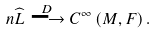Convert formula to latex. <formula><loc_0><loc_0><loc_500><loc_500>n \widehat { L } \stackrel { D } { \longrightarrow } C ^ { \infty } \left ( M , F \right ) .</formula> 